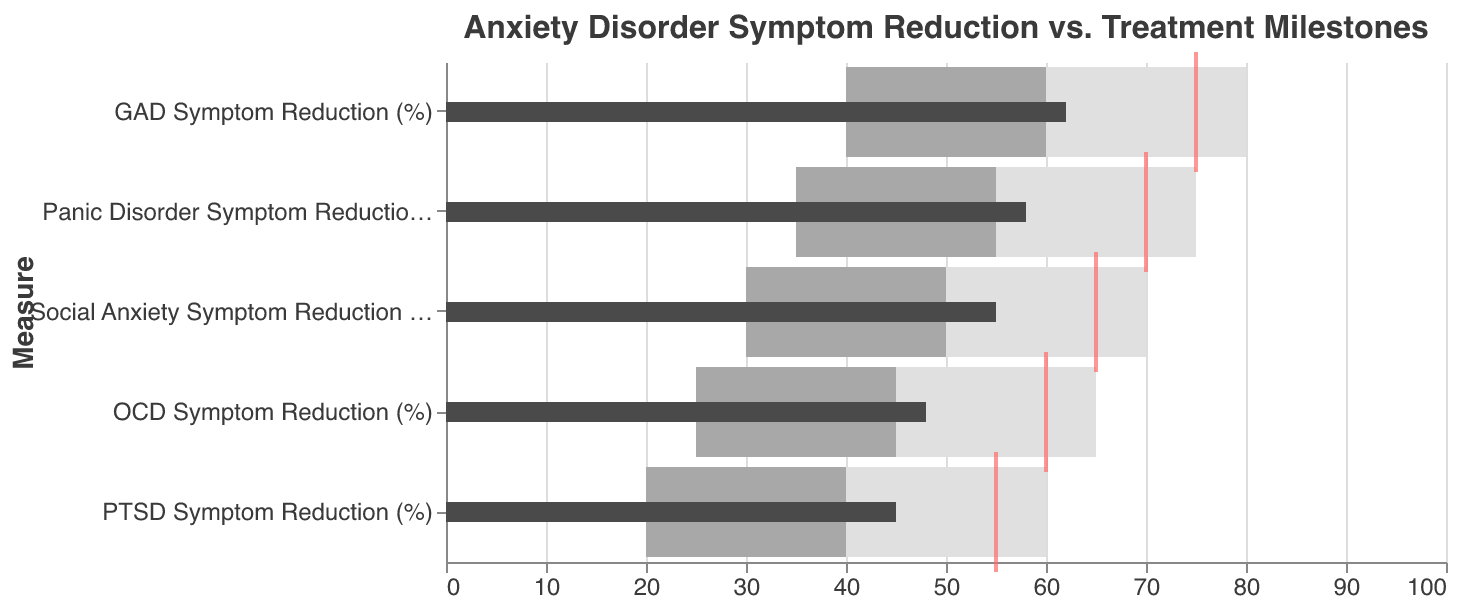What is the title of the figure? The title of the figure is located at the top of the chart and provides an overview of the data being visualized.
Answer: Anxiety Disorder Symptom Reduction vs. Treatment Milestones What is the actual symptom reduction percentage for PTSD? To find the actual symptom reduction percentage for PTSD, look for the "PTSD Symptom Reduction (%)" row and refer to the "Actual" bar.
Answer: 45% Which anxiety disorder has the highest target symptom reduction percentage? Compare the "Target" tick marks for all anxiety disorders to determine which has the highest value.
Answer: GAD (75%) How are "Satisfactory" and "Good" levels indicated in the chart? "Satisfactory" levels are indicated by a medium grey bar, and "Good" levels are indicated by a light grey bar, spanning their respective percentage ranges.
Answer: Medium grey bar for Satisfactory, Light grey bar for Good For which anxiety disorder does the actual symptom reduction percentage come closest to the target percentage? Compare the distances between the "Actual" bars and their respective "Target" tick marks across all disorders.
Answer: GAD (Actual: 62%, Target: 75%) What is the difference between the actual and target symptom reduction percentages for OCD? Locate the "Actual" bar and "Target" tick mark for OCD and calculate the difference.
Answer: 12% Which disorder has an actual reduction falling into the "Poor" category? Determine which "Actual" bars fall within the "Poor" range marked by the darkest grey bars.
Answer: None How many disorders have an actual symptom reduction percentage over 50%? Count the number of "Actual" bars that go beyond the 50% mark on the x-axis.
Answer: 3 (GAD, Panic Disorder, Social Anxiety) Which anxiety disorder has the poorest actual performance relative to the good target range? Identify the disorder with the largest gap between its "Actual" bar and the lower threshold of the "Good" range (typically 80% or 75%).
Answer: PTSD 